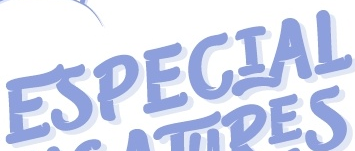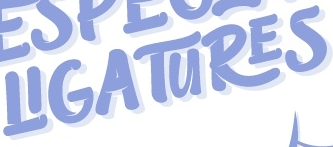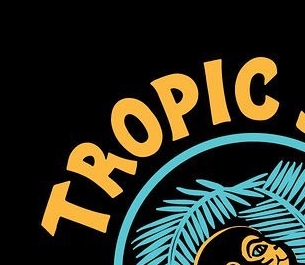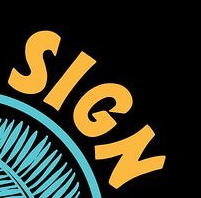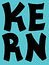Identify the words shown in these images in order, separated by a semicolon. ESPECIAL; LIGATURES; TROPLC; SIGN; KERN 